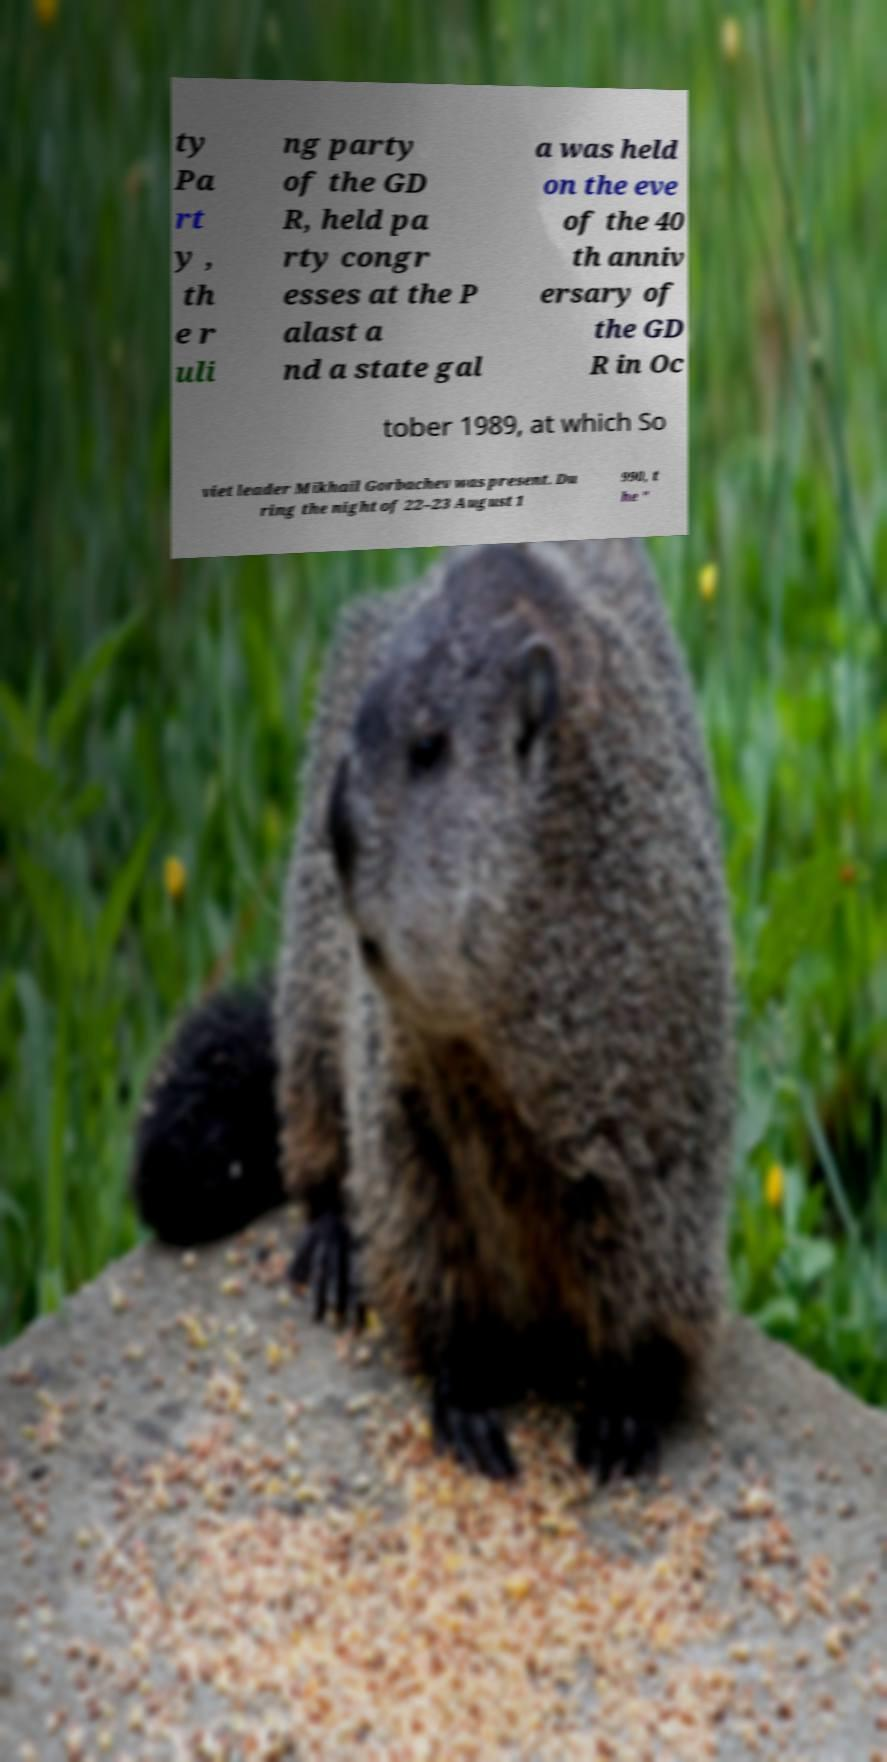For documentation purposes, I need the text within this image transcribed. Could you provide that? ty Pa rt y , th e r uli ng party of the GD R, held pa rty congr esses at the P alast a nd a state gal a was held on the eve of the 40 th anniv ersary of the GD R in Oc tober 1989, at which So viet leader Mikhail Gorbachev was present. Du ring the night of 22–23 August 1 990, t he " 